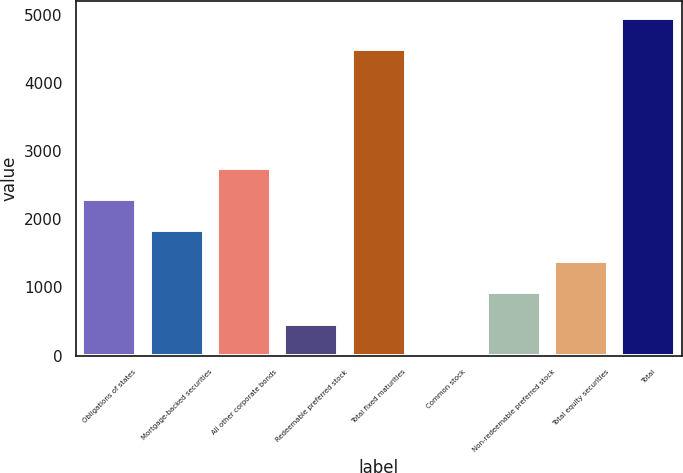Convert chart to OTSL. <chart><loc_0><loc_0><loc_500><loc_500><bar_chart><fcel>Obligations of states<fcel>Mortgage-backed securities<fcel>All other corporate bonds<fcel>Redeemable preferred stock<fcel>Total fixed maturities<fcel>Common stock<fcel>Non-redeemable preferred stock<fcel>Total equity securities<fcel>Total<nl><fcel>2293.5<fcel>1837.2<fcel>2749.8<fcel>468.3<fcel>4494<fcel>12<fcel>924.6<fcel>1380.9<fcel>4950.3<nl></chart> 